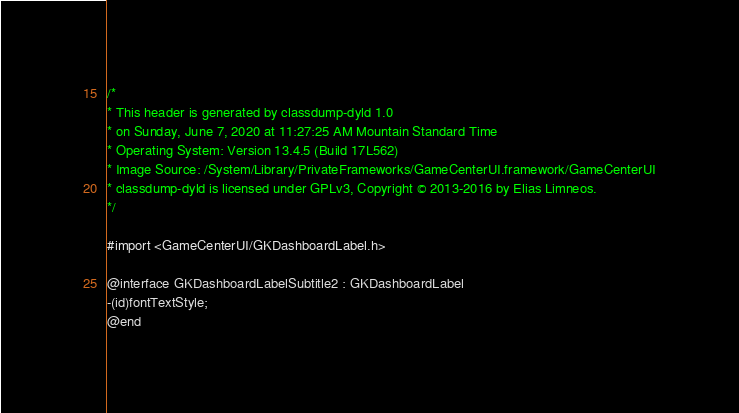Convert code to text. <code><loc_0><loc_0><loc_500><loc_500><_C_>/*
* This header is generated by classdump-dyld 1.0
* on Sunday, June 7, 2020 at 11:27:25 AM Mountain Standard Time
* Operating System: Version 13.4.5 (Build 17L562)
* Image Source: /System/Library/PrivateFrameworks/GameCenterUI.framework/GameCenterUI
* classdump-dyld is licensed under GPLv3, Copyright © 2013-2016 by Elias Limneos.
*/

#import <GameCenterUI/GKDashboardLabel.h>

@interface GKDashboardLabelSubtitle2 : GKDashboardLabel
-(id)fontTextStyle;
@end

</code> 